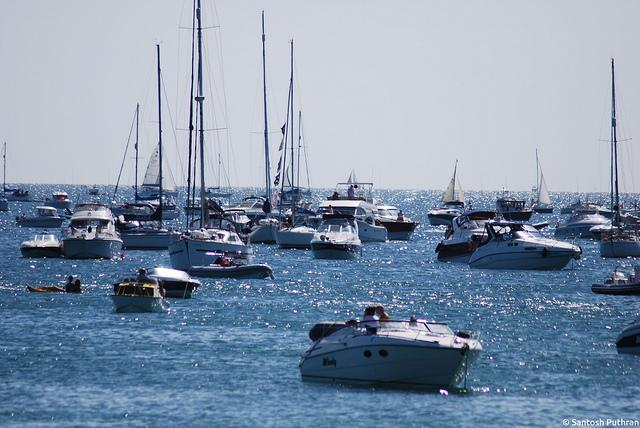Why do some boats have a big pole sticking up from it? Please explain your reasoning. for sails. Wind powered boat have to have something to catch the wind. sheets are strung up on tall poles called "masts". 